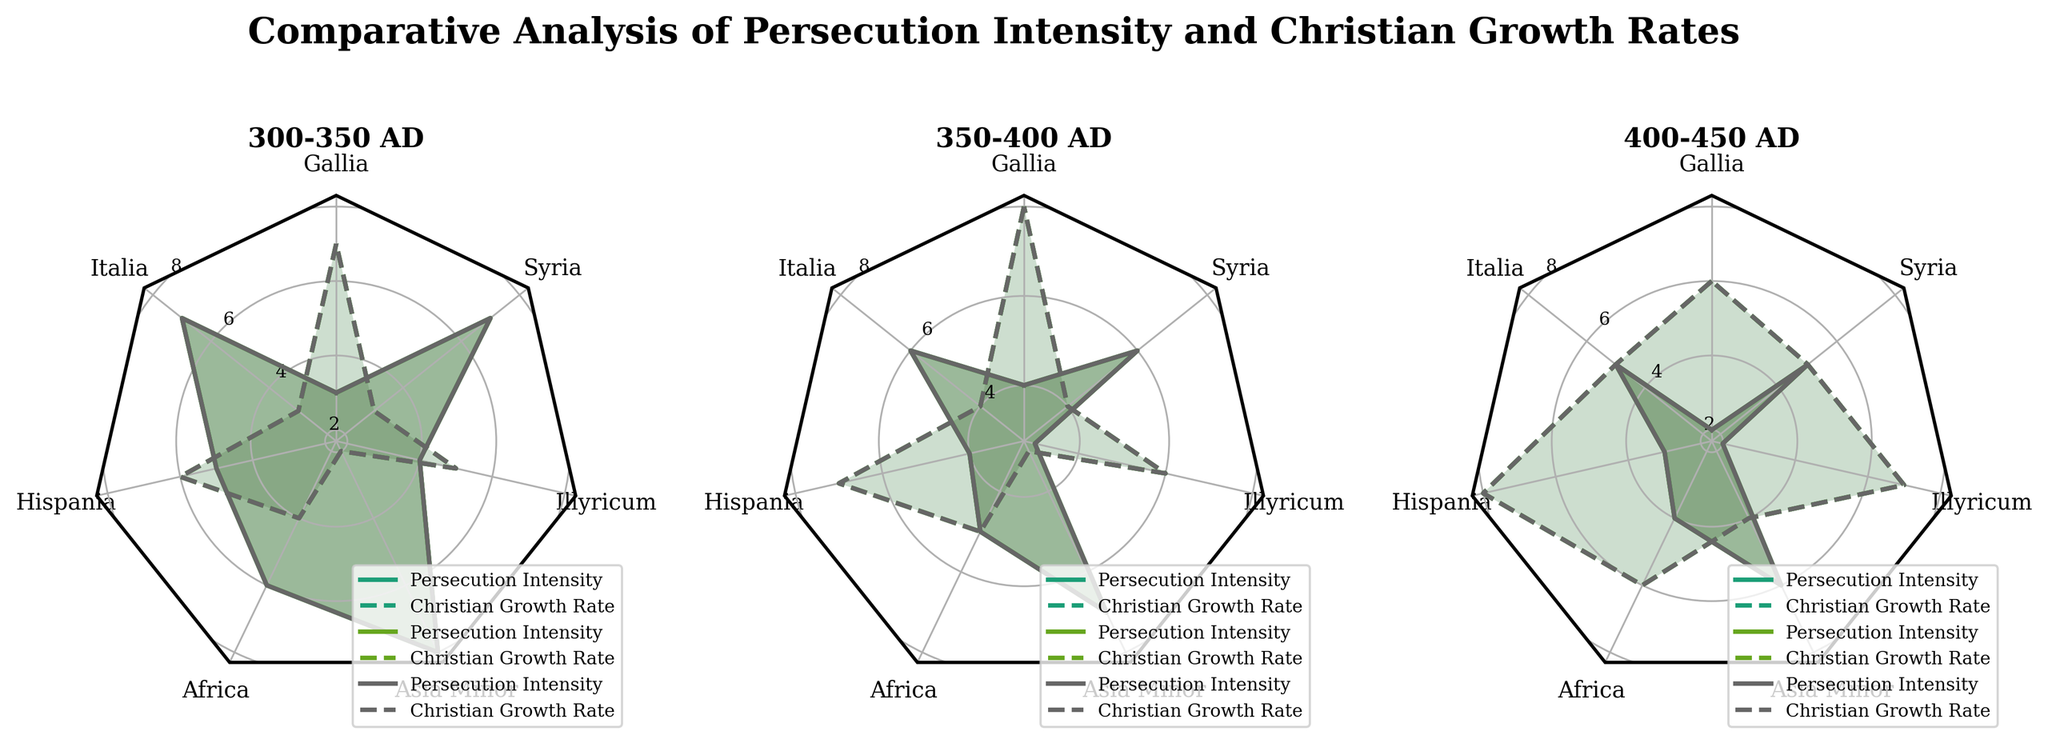How many regions are analyzed in the figure? The radar chart has labels for the number of regions analyzed. Counting each label, there are 7 regions.
Answer: 7 What is the title of the radar chart? The title is located at the top center of the figure. It reads "Comparative Analysis of Persecution Intensity and Christian Growth Rates".
Answer: Comparative Analysis of Persecution Intensity and Christian Growth Rates How does the persecution intensity in Italia change from 300-350 AD to 400-450 AD? Looking at the corresponding radar plots for Italia, the values for persecution intensity are 7, 6, and 5 for each period, showing a decrement over time.
Answer: It decreases Which region had the highest persecution intensity in the period 300-350 AD? For the period 300-350 AD subplot, we look at the regions and their respective persecution intensity values. Asia Minor has the highest value of 8.
Answer: Asia Minor What is the trend of Christian growth rate in Gallia from 300-350 AD to 400-450 AD? Examining the Christian growth rate values for Gallia across each period, we see the values are 7, 8, and 6. The trend shows an increase followed by a decrease.
Answer: Increase then decrease Compare the persecution intensity and Christian growth rate in Africa during 350-400 AD. Which one is higher? Checking the subplot for 350-400 AD for Africa, the persecution intensity is 5 and the Christian growth rate is 5. Both values are equal.
Answer: Equal Which period shows the lowest persecution intensity for Illyricum? By analyzing the three subplots, the persecution intensity for Illyricum in 400-450 AD is the lowest at a value of 2.
Answer: 400-450 AD Does Syria have an increasing or decreasing trend in persecution intensity over time? Looking at Syria's persecution intensity values of 7, 6, and 5 over the three periods, it shows a clear decreasing trend.
Answer: Decreasing Which region has a higher Christian growth rate than its persecution intensity in the period 400-450 AD? In the 400-450 AD subplot, compare the values of Christian growth rate and persecution intensity for each region. Gallia (6 > 2), Hispania (8 > 3), Africa (6 > 4), Illyricum (7 > 2) all have higher Christian growth rates than persecution intensity.
Answer: Gallia, Hispania, Africa, Illyricum How does the persecution intensity in Asia Minor compare between 300-350 AD and 400-450 AD? We observe the persecution intensity for Asia Minor for the two periods, which are 8 for 300-350 AD, and 6 for 400-450 AD. This shows a decrease.
Answer: It decreases 